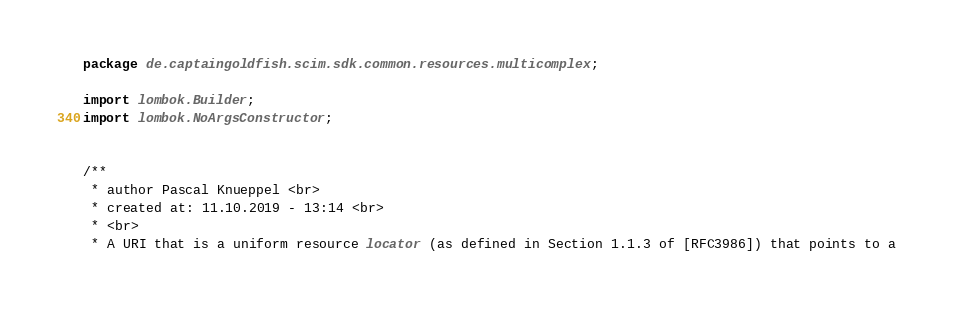Convert code to text. <code><loc_0><loc_0><loc_500><loc_500><_Java_>package de.captaingoldfish.scim.sdk.common.resources.multicomplex;

import lombok.Builder;
import lombok.NoArgsConstructor;


/**
 * author Pascal Knueppel <br>
 * created at: 11.10.2019 - 13:14 <br>
 * <br>
 * A URI that is a uniform resource locator (as defined in Section 1.1.3 of [RFC3986]) that points to a</code> 